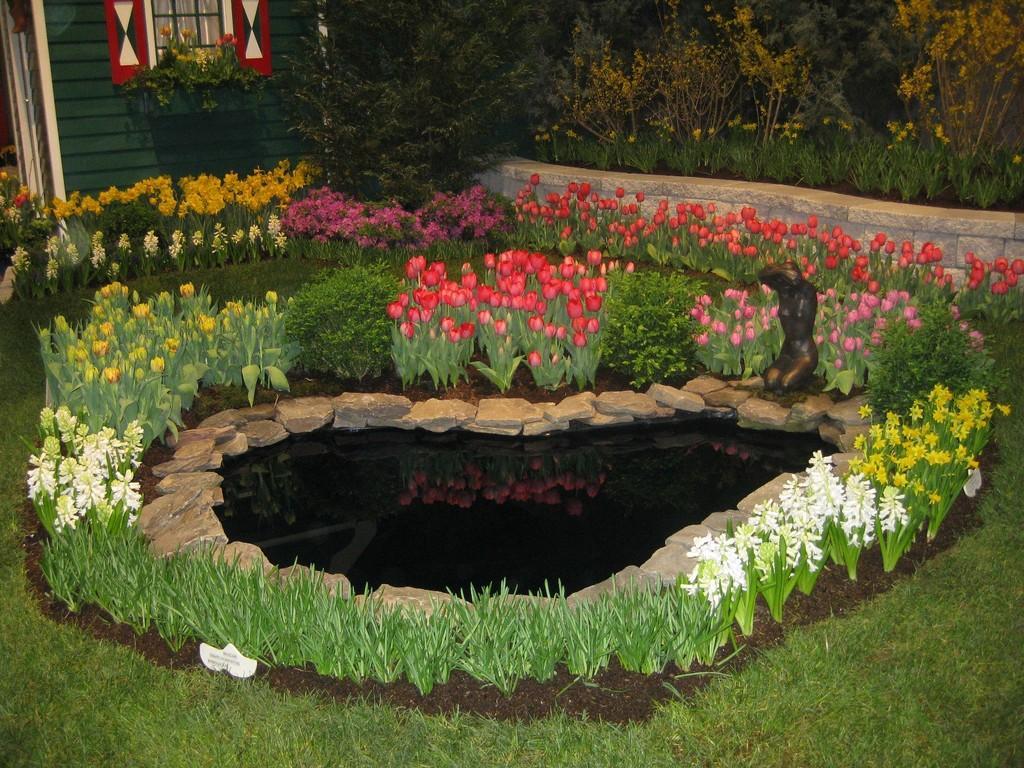Could you give a brief overview of what you see in this image? In this picture I can see there is a pond, there are few rocks, plants with different flowers, there is some grass on the floor. There is a building on left side, with a window. 